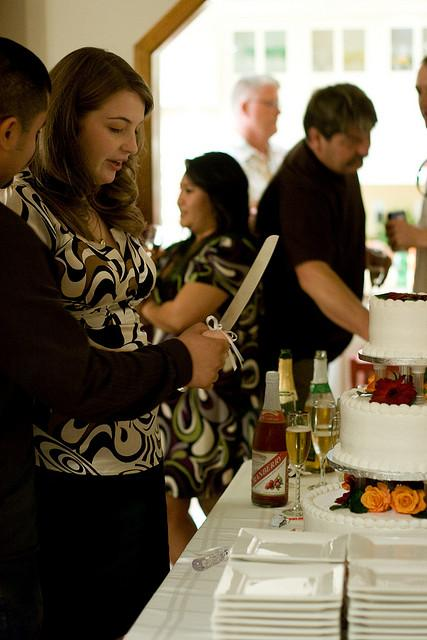What did this lady do on the day she holds this knife? Please explain your reasoning. marry. The cake is a wedding cake. 